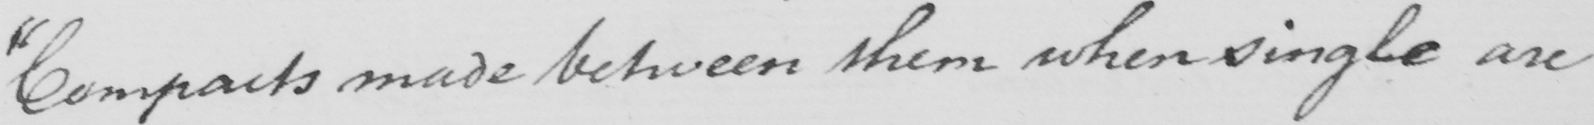Please transcribe the handwritten text in this image. " Compacts made between them when single are 